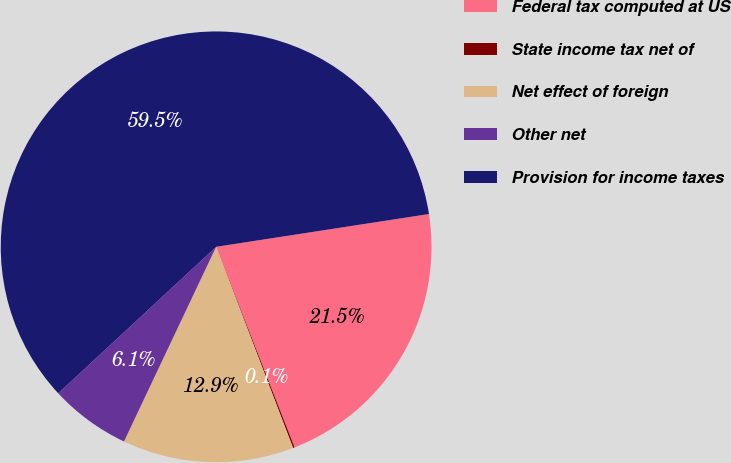Convert chart to OTSL. <chart><loc_0><loc_0><loc_500><loc_500><pie_chart><fcel>Federal tax computed at US<fcel>State income tax net of<fcel>Net effect of foreign<fcel>Other net<fcel>Provision for income taxes<nl><fcel>21.5%<fcel>0.12%<fcel>12.85%<fcel>6.06%<fcel>59.47%<nl></chart> 